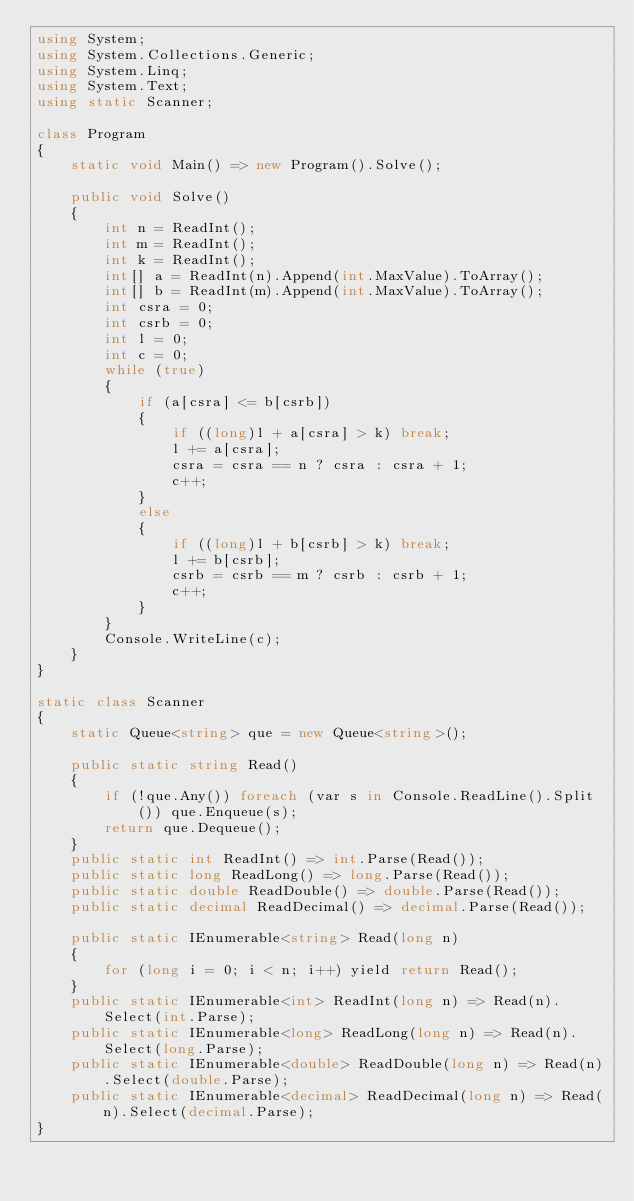<code> <loc_0><loc_0><loc_500><loc_500><_C#_>using System;
using System.Collections.Generic;
using System.Linq;
using System.Text;
using static Scanner;

class Program
{
    static void Main() => new Program().Solve();

    public void Solve()
    {
        int n = ReadInt();
        int m = ReadInt();
        int k = ReadInt();
        int[] a = ReadInt(n).Append(int.MaxValue).ToArray();
        int[] b = ReadInt(m).Append(int.MaxValue).ToArray();
        int csra = 0;
        int csrb = 0;
        int l = 0;
        int c = 0;
        while (true)
        {
            if (a[csra] <= b[csrb])
            {
                if ((long)l + a[csra] > k) break;
                l += a[csra];
                csra = csra == n ? csra : csra + 1;
                c++;
            }
            else
            {
                if ((long)l + b[csrb] > k) break;
                l += b[csrb];
                csrb = csrb == m ? csrb : csrb + 1;
                c++;
            }
        }
        Console.WriteLine(c);
    }
}

static class Scanner
{
    static Queue<string> que = new Queue<string>();

    public static string Read()
    {
        if (!que.Any()) foreach (var s in Console.ReadLine().Split()) que.Enqueue(s);
        return que.Dequeue();
    }
    public static int ReadInt() => int.Parse(Read());
    public static long ReadLong() => long.Parse(Read());
    public static double ReadDouble() => double.Parse(Read());
    public static decimal ReadDecimal() => decimal.Parse(Read());

    public static IEnumerable<string> Read(long n)
    {
        for (long i = 0; i < n; i++) yield return Read();
    }
    public static IEnumerable<int> ReadInt(long n) => Read(n).Select(int.Parse);
    public static IEnumerable<long> ReadLong(long n) => Read(n).Select(long.Parse);
    public static IEnumerable<double> ReadDouble(long n) => Read(n).Select(double.Parse);
    public static IEnumerable<decimal> ReadDecimal(long n) => Read(n).Select(decimal.Parse);
}</code> 